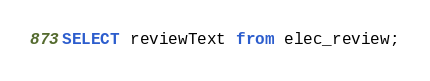<code> <loc_0><loc_0><loc_500><loc_500><_SQL_>SELECT reviewText from elec_review;</code> 